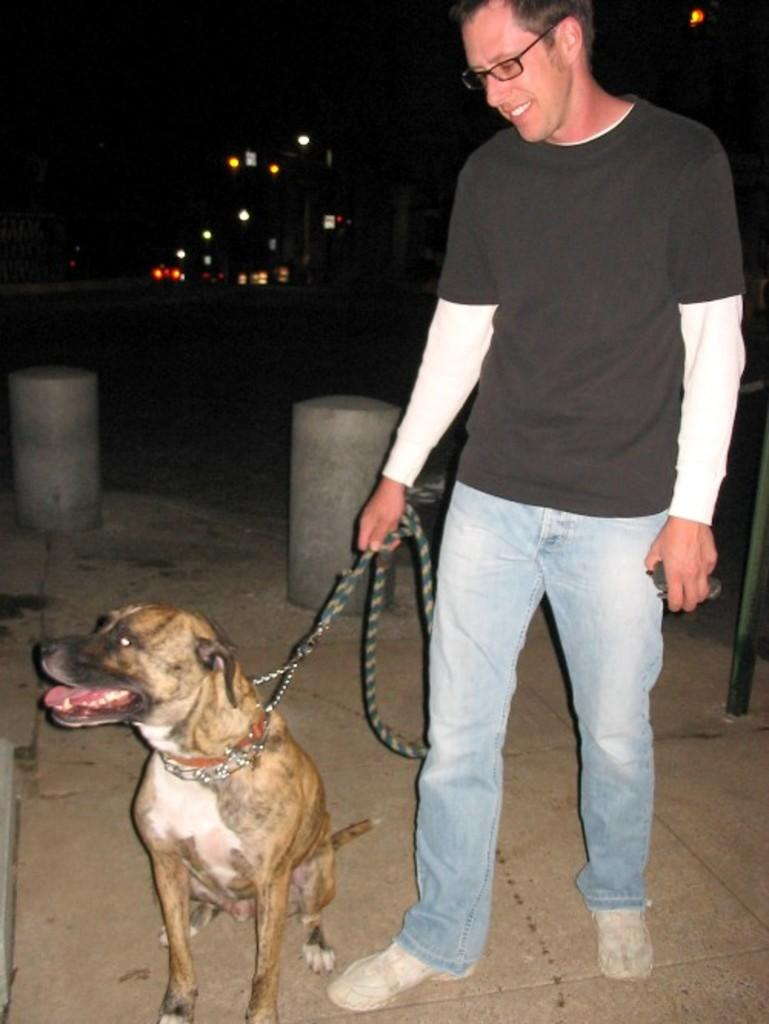Who is present in the image? There is a man in the image. What is the man doing in the image? The man is smiling and holding a dog with a thread. What can be seen in the distance in the image? There are lights visible in the distance. What type of paint is being used by the man in the image? There is no indication in the image that the man is using paint; he is holding a dog with a thread and smiling. 